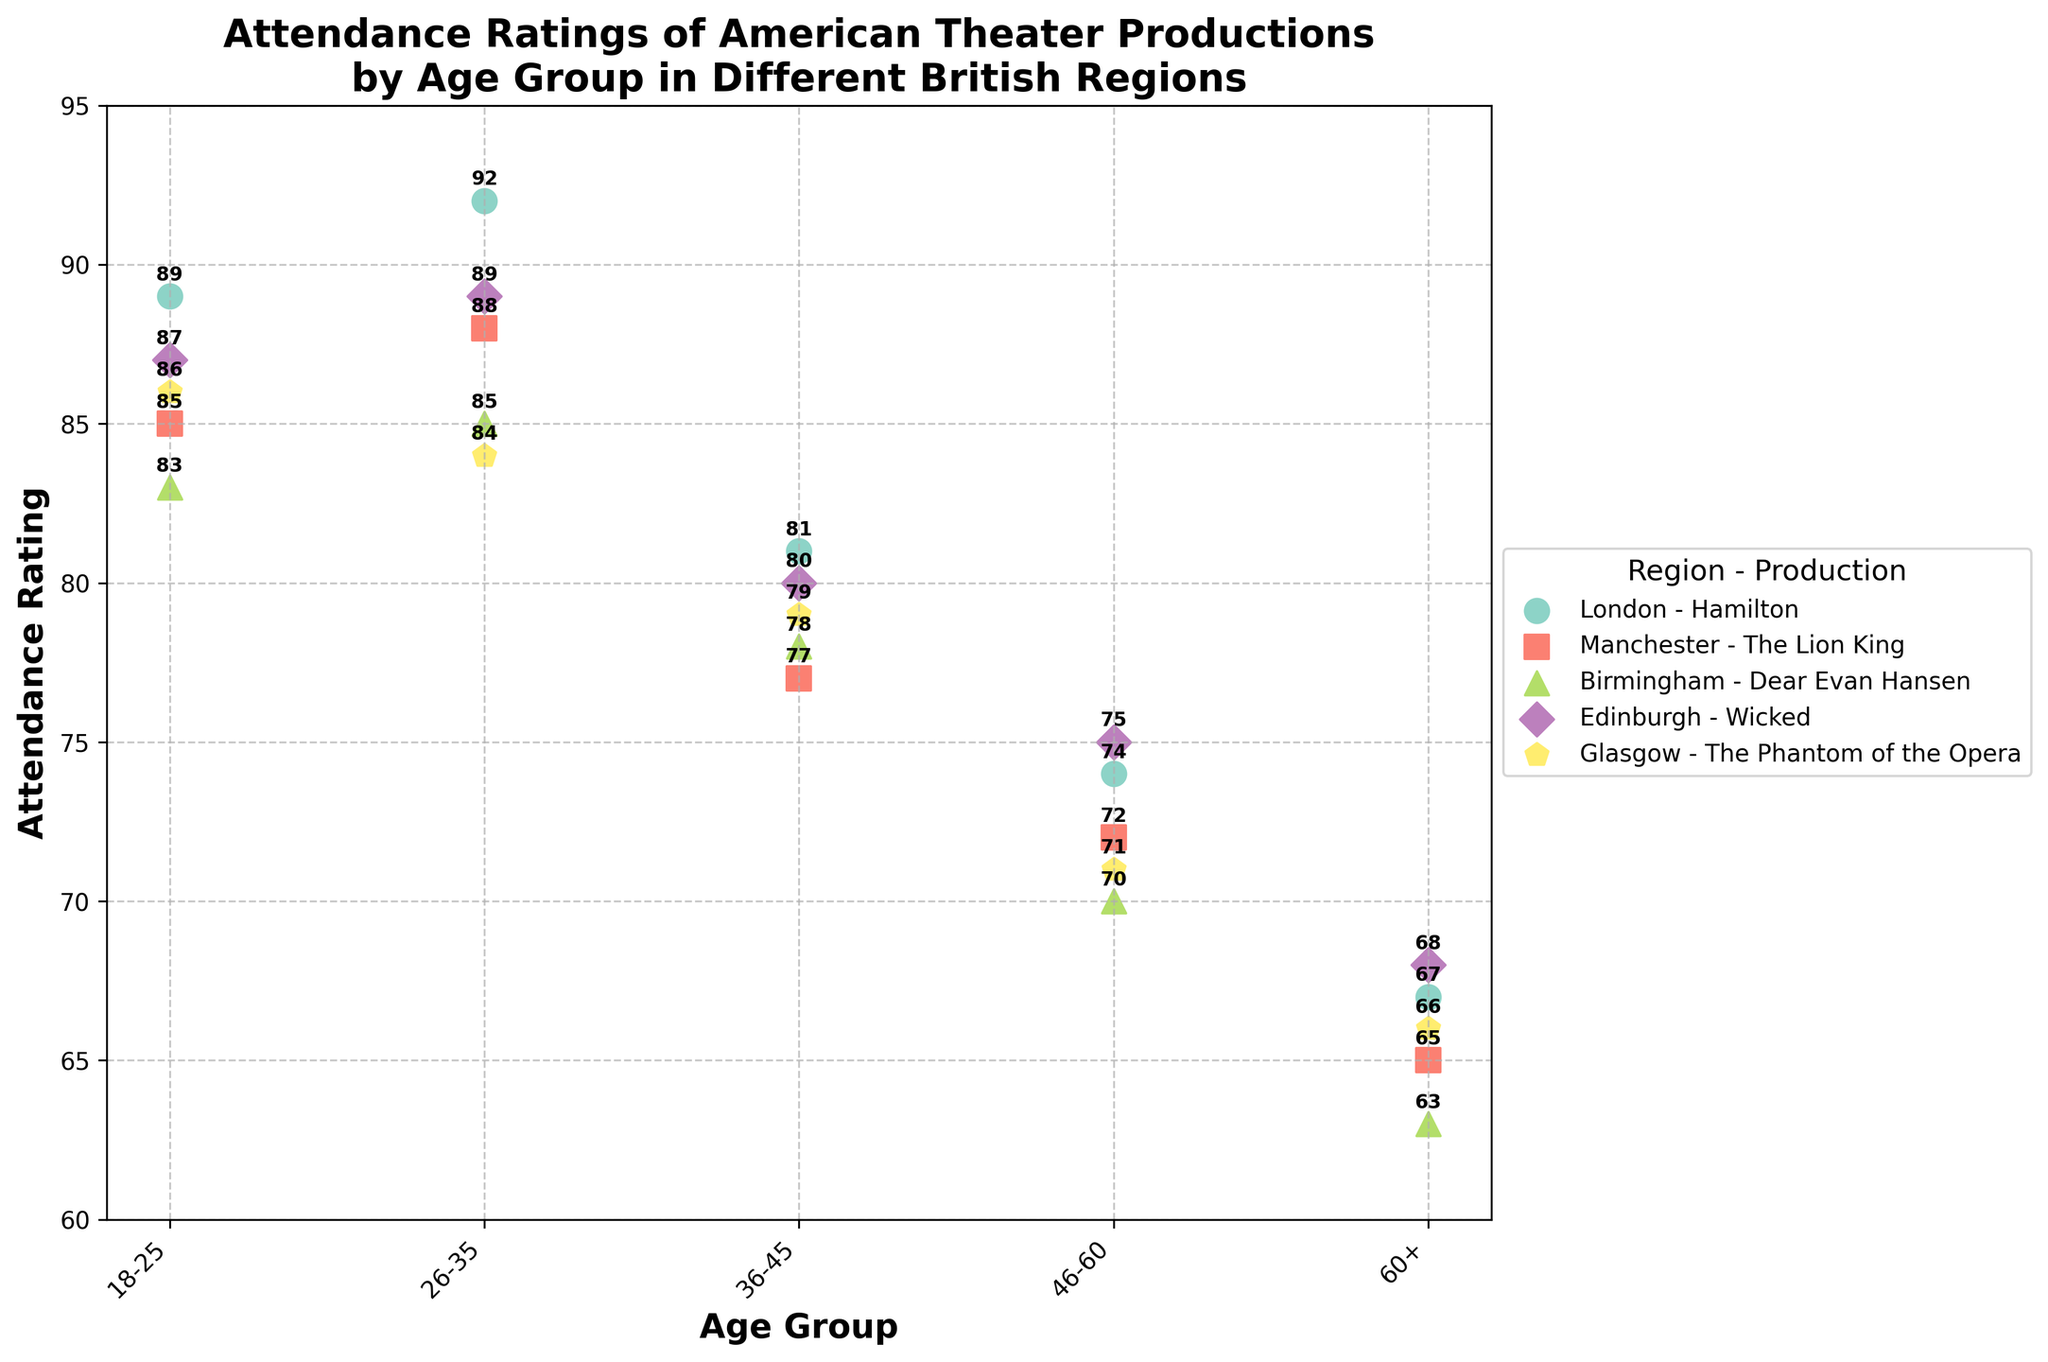What is the title of the figure? The title is usually displayed at the top of the figure. Here, it is given as "Attendance Ratings of American Theater Productions by Age Group in Different British Regions".
Answer: Attendance Ratings of American Theater Productions by Age Group in Different British Regions Which age group in London has the highest attendance rating for Hamilton? By looking at the points under 'London' and finding the highest y-value (rating), we see the age group is 26-35 with a rating of 92.
Answer: 26-35 What is the attendance rating for the 60+ age group in Manchester for "The Lion King"? We locate the data points for Manchester and check the rating associated with the 60+ age group, which is 65.
Answer: 65 How does the attendance rating for the 18-25 age group compare between London and Glasgow? We find the 18-25 points for both London (89) and Glasgow (86). By comparing, 89 is higher than 86.
Answer: London is higher than Glasgow What is the average attendance rating for all age groups in Birmingham for "Dear Evan Hansen"? Sum up the ratings for Birmingham: (83 + 85 + 78 + 70 + 63) = 379. Divide by the number of age groups, which is 5. So, 379/5 = 75.8.
Answer: 75.8 Which region has the lowest attendance rating for the 46-60 age group and what is the rating? Checking each region's 46-60 data, the lowest rating is in Birmingham for "Dear Evan Hansen" with a rating of 70.
Answer: Birmingham, 70 In which region is the average attendance rating for the 36-45 age group highest? Calculate the average rating for each region's 36-45 age group: 
London (81), 
Manchester (77), 
Birmingham (78), 
Edinburgh (80), 
Glasgow (79). 
The highest is London with 81.
Answer: London How many different age groups are represented in the figure? Observe the x-ticks representing age groups (18-25, 26-35, 36-45, 46-60, 60+). There are 5 different age groups.
Answer: 5 Does Edinburgh have a higher attendance rating than Manchester for the 26-35 age group? Compare Edinburgh's 26-35 rating (89) with Manchester's 26-35 rating (88). Edinburgh's is higher.
Answer: Yes What is the range of attendance ratings for "The Phantom of the Opera" in Glasgow? Find the highest (86 for the 18-25 age group) and the lowest (66 for the 60+ age group) ratings in Glasgow. The range is 86 - 66 = 20.
Answer: 20 